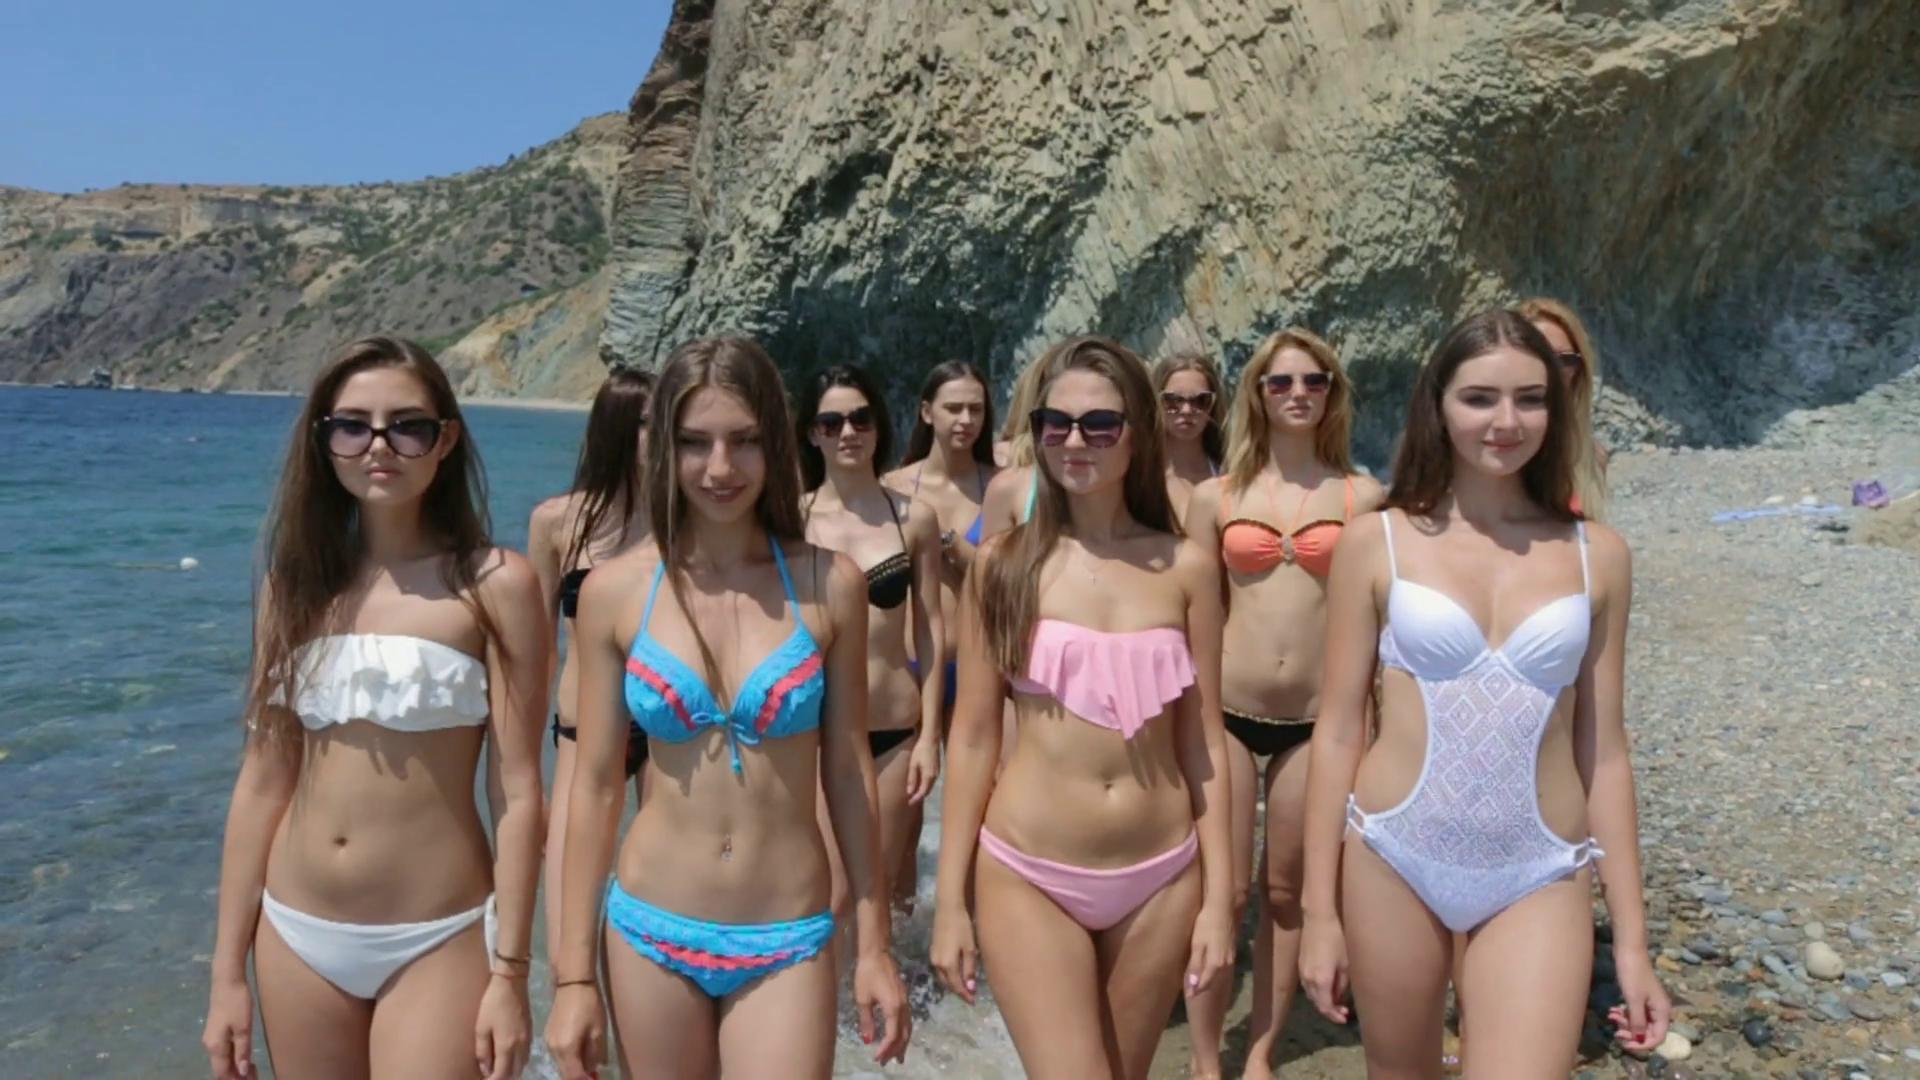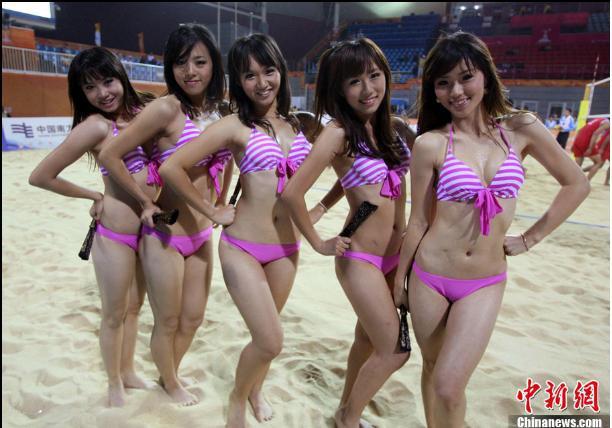The first image is the image on the left, the second image is the image on the right. Analyze the images presented: Is the assertion "In at least one image there is at least six bodybuilders in bikinis." valid? Answer yes or no. No. The first image is the image on the left, the second image is the image on the right. Examine the images to the left and right. Is the description "The women in the right image are wearing matching bikinis." accurate? Answer yes or no. Yes. 